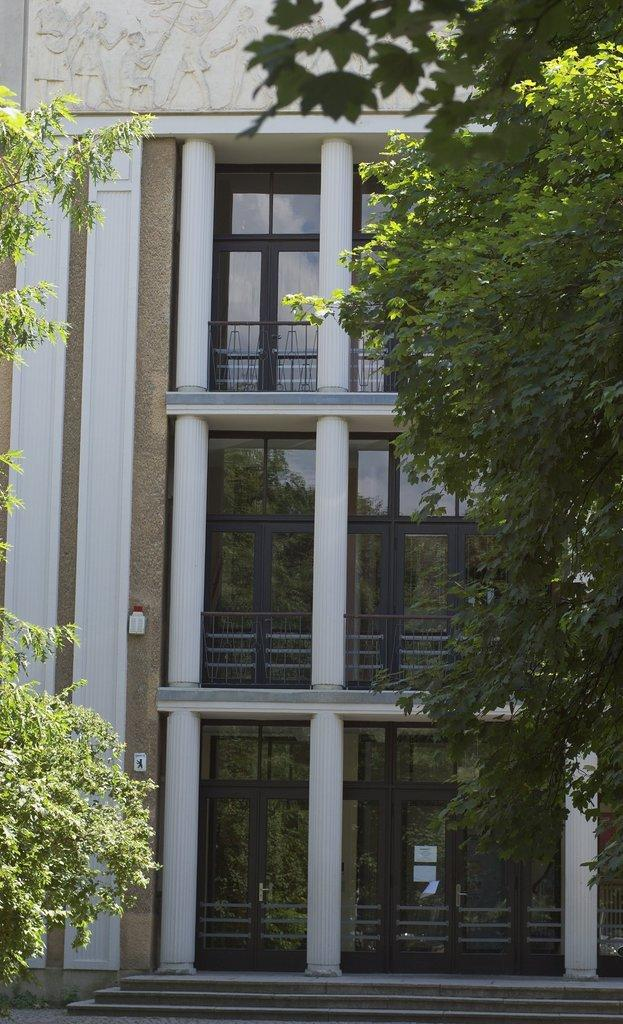What type of structure is visible in the image? There is a building in the image. What features can be seen on the building? The building has doors and balconies. What can be seen on the sides of the image? There are trees on both the left and right sides of the image. Can you describe the trees in the image? The trees are located on both the left and right sides of the image. What type of pig can be seen learning to use a blade in the image? There is no pig or blade present in the image. 